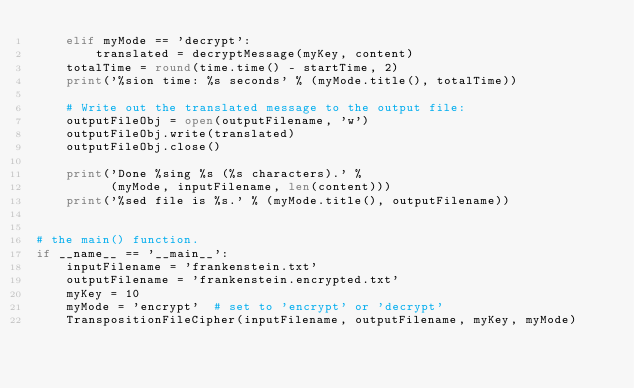<code> <loc_0><loc_0><loc_500><loc_500><_Python_>    elif myMode == 'decrypt':
        translated = decryptMessage(myKey, content)
    totalTime = round(time.time() - startTime, 2)
    print('%sion time: %s seconds' % (myMode.title(), totalTime))

    # Write out the translated message to the output file:
    outputFileObj = open(outputFilename, 'w')
    outputFileObj.write(translated)
    outputFileObj.close()

    print('Done %sing %s (%s characters).' %
          (myMode, inputFilename, len(content)))
    print('%sed file is %s.' % (myMode.title(), outputFilename))


# the main() function.
if __name__ == '__main__':
    inputFilename = 'frankenstein.txt'
    outputFilename = 'frankenstein.encrypted.txt'
    myKey = 10
    myMode = 'encrypt'  # set to 'encrypt' or 'decrypt'
    TranspositionFileCipher(inputFilename, outputFilename, myKey, myMode)
</code> 